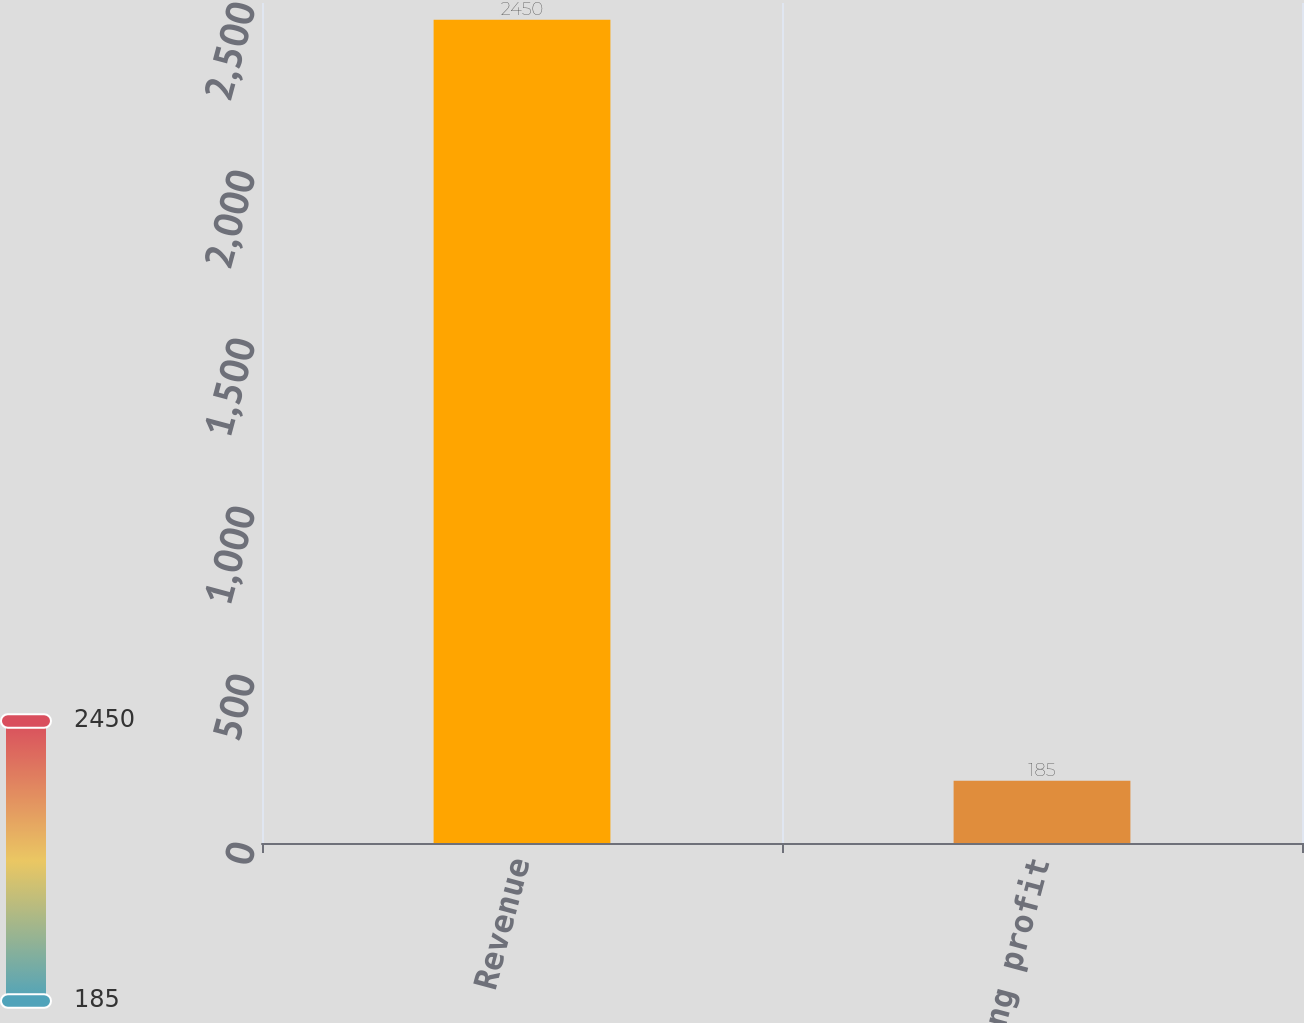Convert chart. <chart><loc_0><loc_0><loc_500><loc_500><bar_chart><fcel>Revenue<fcel>Operating profit<nl><fcel>2450<fcel>185<nl></chart> 